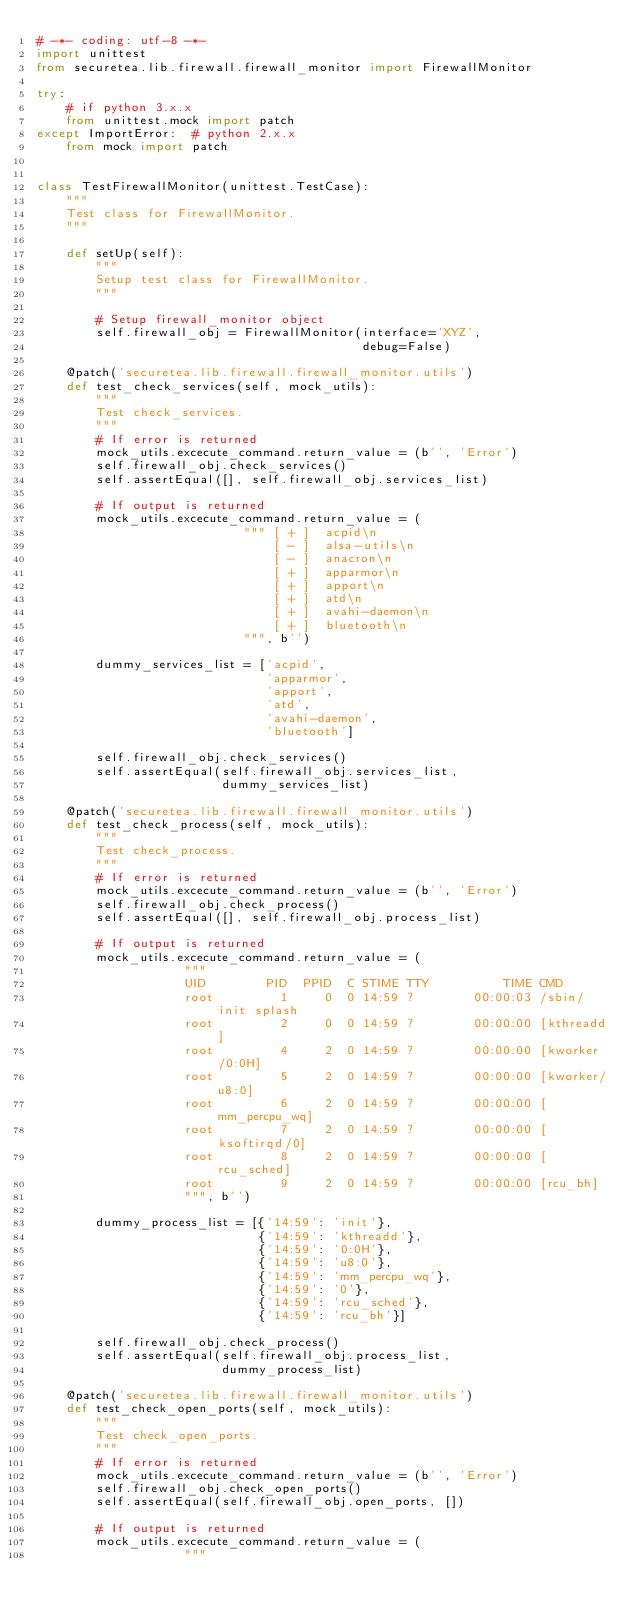Convert code to text. <code><loc_0><loc_0><loc_500><loc_500><_Python_># -*- coding: utf-8 -*-
import unittest
from securetea.lib.firewall.firewall_monitor import FirewallMonitor

try:
    # if python 3.x.x
    from unittest.mock import patch
except ImportError:  # python 2.x.x
    from mock import patch


class TestFirewallMonitor(unittest.TestCase):
    """
    Test class for FirewallMonitor.
    """

    def setUp(self):
        """
        Setup test class for FirewallMonitor.
        """

        # Setup firewall_monitor object
        self.firewall_obj = FirewallMonitor(interface='XYZ',
                                            debug=False)

    @patch('securetea.lib.firewall.firewall_monitor.utils')
    def test_check_services(self, mock_utils):
        """
        Test check_services.
        """
        # If error is returned
        mock_utils.excecute_command.return_value = (b'', 'Error')
        self.firewall_obj.check_services()
        self.assertEqual([], self.firewall_obj.services_list)

        # If output is returned
        mock_utils.excecute_command.return_value = (
                            """ [ + ]  acpid\n
                                [ - ]  alsa-utils\n
                                [ - ]  anacron\n
                                [ + ]  apparmor\n
                                [ + ]  apport\n
                                [ + ]  atd\n
                                [ + ]  avahi-daemon\n
                                [ + ]  bluetooth\n
                            """, b'')

        dummy_services_list = ['acpid',
                               'apparmor',
                               'apport',
                               'atd',
                               'avahi-daemon',
                               'bluetooth']

        self.firewall_obj.check_services()
        self.assertEqual(self.firewall_obj.services_list,
                         dummy_services_list)

    @patch('securetea.lib.firewall.firewall_monitor.utils')
    def test_check_process(self, mock_utils):
        """
        Test check_process.
        """
        # If error is returned
        mock_utils.excecute_command.return_value = (b'', 'Error')
        self.firewall_obj.check_process()
        self.assertEqual([], self.firewall_obj.process_list)

        # If output is returned
        mock_utils.excecute_command.return_value = (
                    """
                    UID        PID  PPID  C STIME TTY          TIME CMD
                    root         1     0  0 14:59 ?        00:00:03 /sbin/init splash
                    root         2     0  0 14:59 ?        00:00:00 [kthreadd]
                    root         4     2  0 14:59 ?        00:00:00 [kworker/0:0H]
                    root         5     2  0 14:59 ?        00:00:00 [kworker/u8:0]
                    root         6     2  0 14:59 ?        00:00:00 [mm_percpu_wq]
                    root         7     2  0 14:59 ?        00:00:00 [ksoftirqd/0]
                    root         8     2  0 14:59 ?        00:00:00 [rcu_sched]
                    root         9     2  0 14:59 ?        00:00:00 [rcu_bh]
                    """, b'')

        dummy_process_list = [{'14:59': 'init'},
                              {'14:59': 'kthreadd'},
                              {'14:59': '0:0H'},
                              {'14:59': 'u8:0'},
                              {'14:59': 'mm_percpu_wq'},
                              {'14:59': '0'},
                              {'14:59': 'rcu_sched'},
                              {'14:59': 'rcu_bh'}]

        self.firewall_obj.check_process()
        self.assertEqual(self.firewall_obj.process_list,
                         dummy_process_list)

    @patch('securetea.lib.firewall.firewall_monitor.utils')
    def test_check_open_ports(self, mock_utils):
        """
        Test check_open_ports.
        """
        # If error is returned
        mock_utils.excecute_command.return_value = (b'', 'Error')
        self.firewall_obj.check_open_ports()
        self.assertEqual(self.firewall_obj.open_ports, [])

        # If output is returned
        mock_utils.excecute_command.return_value = (
                    """</code> 